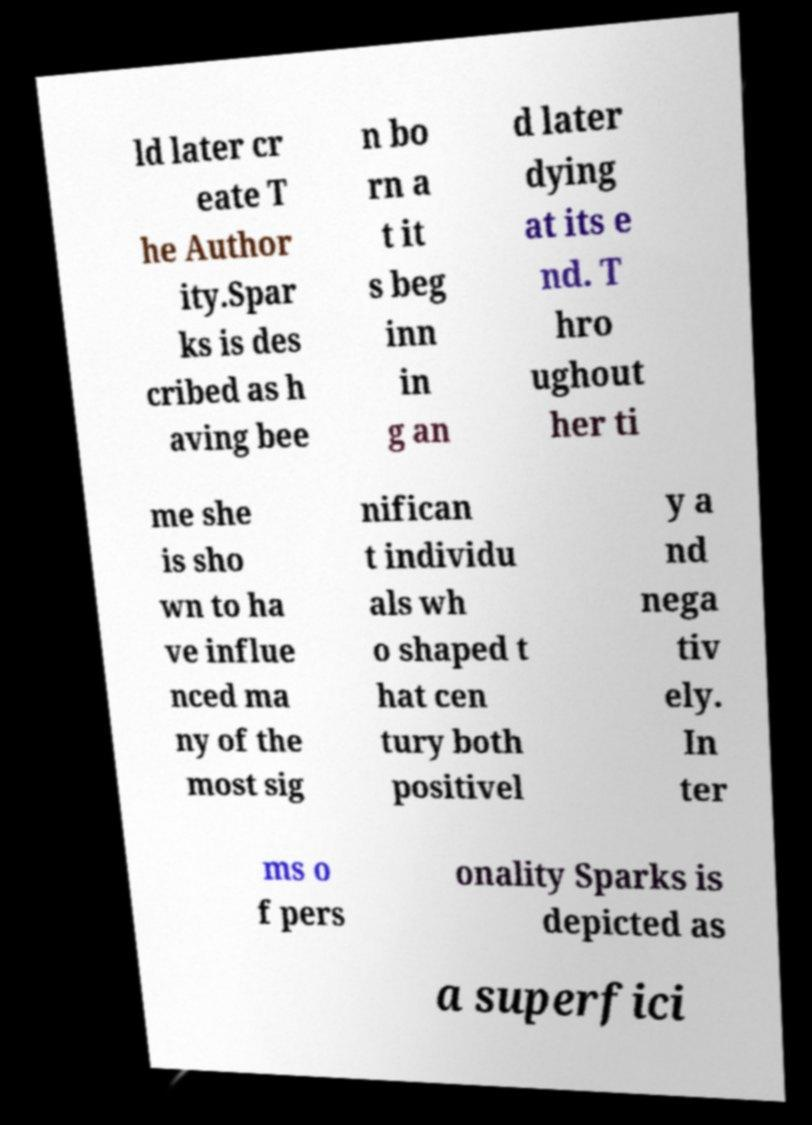Could you extract and type out the text from this image? ld later cr eate T he Author ity.Spar ks is des cribed as h aving bee n bo rn a t it s beg inn in g an d later dying at its e nd. T hro ughout her ti me she is sho wn to ha ve influe nced ma ny of the most sig nifican t individu als wh o shaped t hat cen tury both positivel y a nd nega tiv ely. In ter ms o f pers onality Sparks is depicted as a superfici 